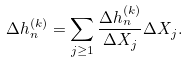<formula> <loc_0><loc_0><loc_500><loc_500>\Delta h _ { n } ^ { ( k ) } = \sum _ { j \geq 1 } \frac { \Delta h _ { n } ^ { ( k ) } } { \Delta X _ { j } } \Delta X _ { j } .</formula> 